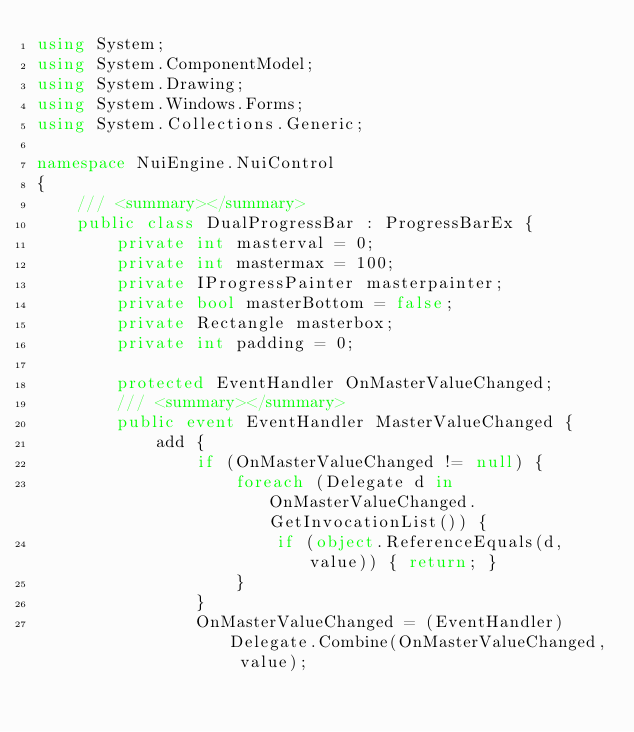<code> <loc_0><loc_0><loc_500><loc_500><_C#_>using System;
using System.ComponentModel;
using System.Drawing;
using System.Windows.Forms;
using System.Collections.Generic;

namespace NuiEngine.NuiControl
{
	/// <summary></summary>
	public class DualProgressBar : ProgressBarEx {
		private int masterval = 0;
		private int mastermax = 100;
		private IProgressPainter masterpainter;
		private bool masterBottom = false;
		private Rectangle masterbox;
		private int padding = 0;

		protected EventHandler OnMasterValueChanged;
		/// <summary></summary>
		public event EventHandler MasterValueChanged {
			add {
				if (OnMasterValueChanged != null) {
					foreach (Delegate d in OnMasterValueChanged.GetInvocationList()) {
						if (object.ReferenceEquals(d, value)) { return; }
					}
				}
				OnMasterValueChanged = (EventHandler)Delegate.Combine(OnMasterValueChanged, value);</code> 